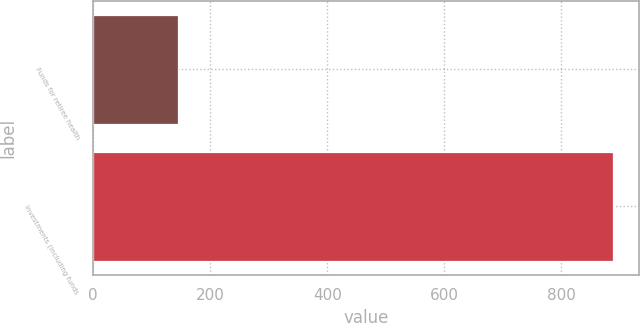Convert chart to OTSL. <chart><loc_0><loc_0><loc_500><loc_500><bar_chart><fcel>Funds for retiree health<fcel>Investments (including funds<nl><fcel>145<fcel>888<nl></chart> 